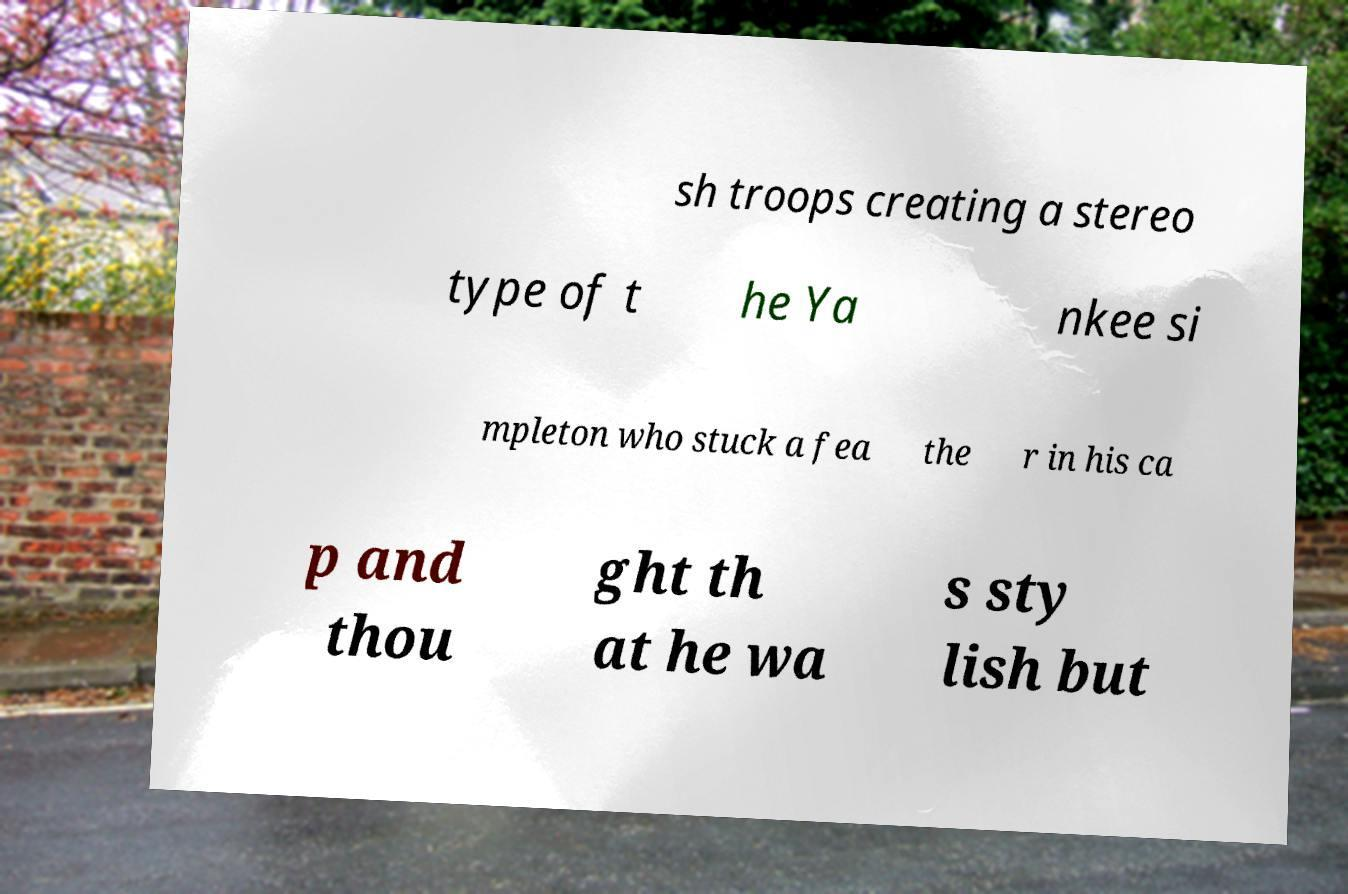Please identify and transcribe the text found in this image. sh troops creating a stereo type of t he Ya nkee si mpleton who stuck a fea the r in his ca p and thou ght th at he wa s sty lish but 